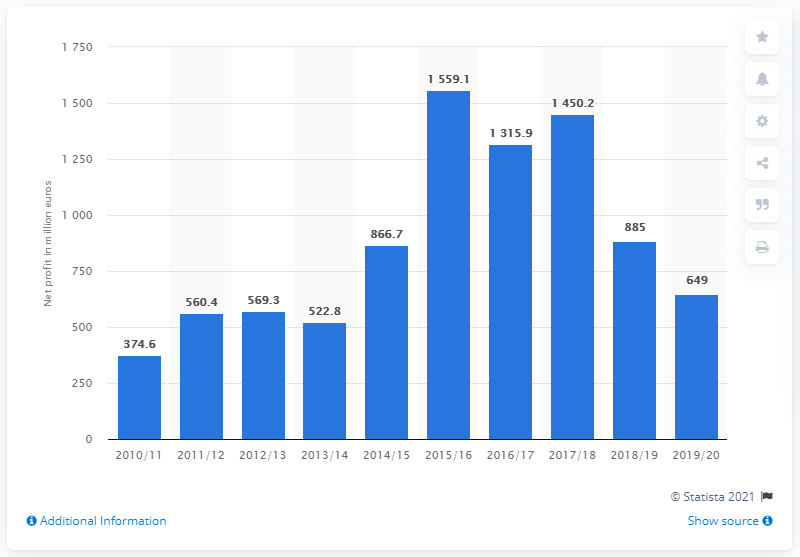Mention a couple of crucial points in this snapshot. Ryanair's net profit for the fiscal year 2017/18 was 1,450.2 million euros. 